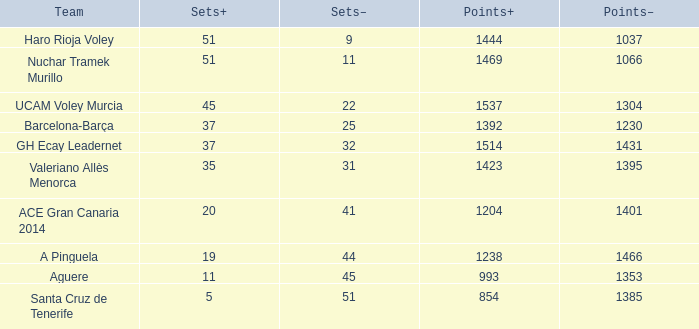What is the highest Points+ number that has a Sets+ number larger than 45, a Sets- number larger than 9, and a Points- number smaller than 1066? None. 